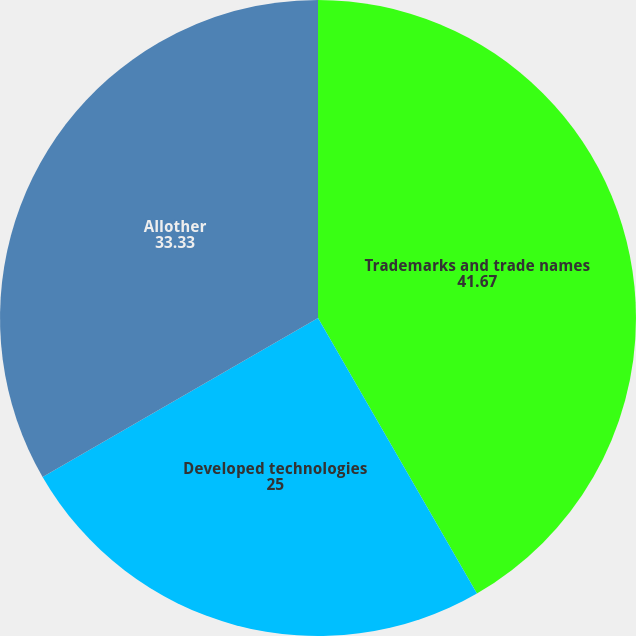<chart> <loc_0><loc_0><loc_500><loc_500><pie_chart><fcel>Trademarks and trade names<fcel>Developed technologies<fcel>Allother<nl><fcel>41.67%<fcel>25.0%<fcel>33.33%<nl></chart> 